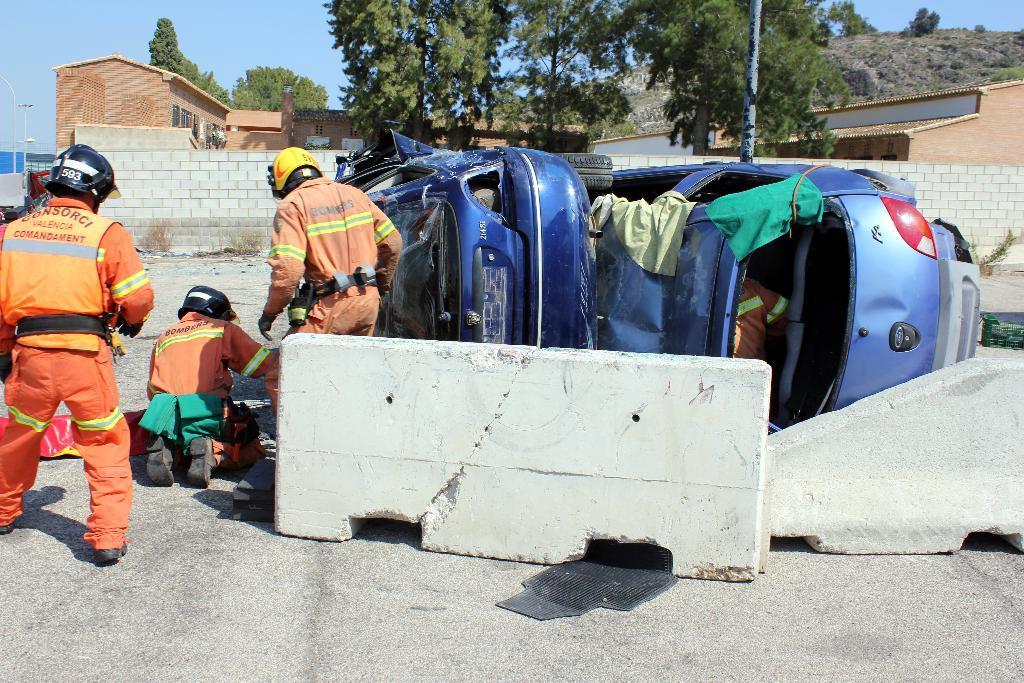In one or two sentences, can you explain what this image depicts? On the left side there are three people wearing helmets. Near to them there are barricades. Also there are vehicles. In the background there is a wall, buildings, trees and sky. 